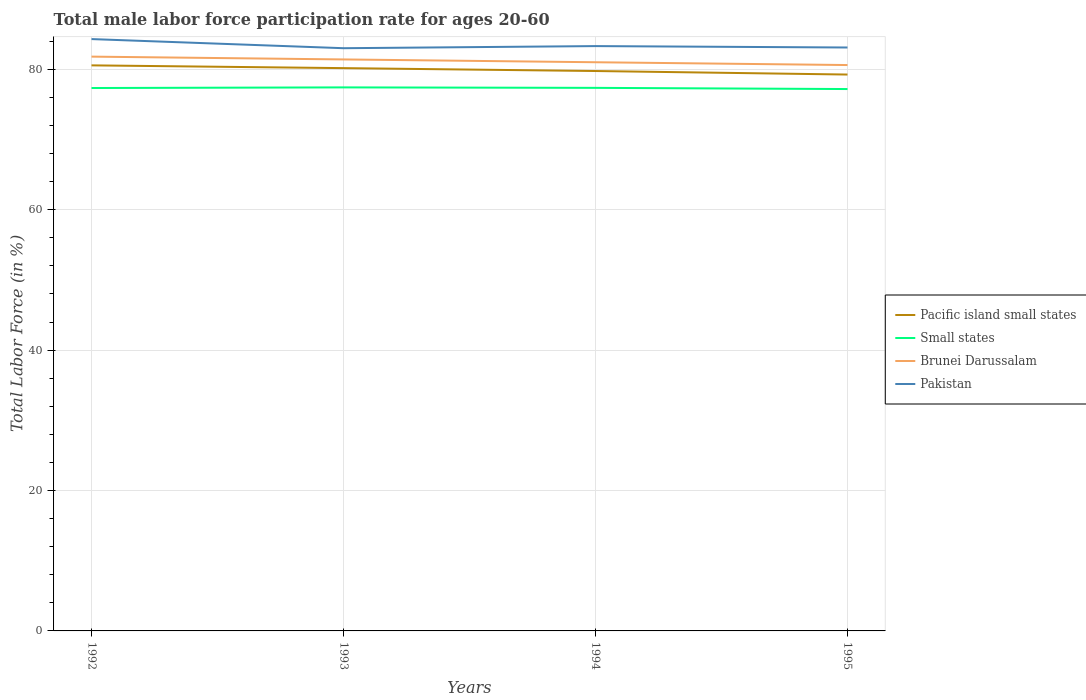Across all years, what is the maximum male labor force participation rate in Pacific island small states?
Provide a short and direct response. 79.25. In which year was the male labor force participation rate in Small states maximum?
Provide a succinct answer. 1995. What is the total male labor force participation rate in Brunei Darussalam in the graph?
Your answer should be very brief. 0.4. What is the difference between the highest and the second highest male labor force participation rate in Pacific island small states?
Ensure brevity in your answer.  1.31. What is the difference between the highest and the lowest male labor force participation rate in Brunei Darussalam?
Your answer should be compact. 2. How many lines are there?
Offer a very short reply. 4. What is the difference between two consecutive major ticks on the Y-axis?
Ensure brevity in your answer.  20. Does the graph contain grids?
Your response must be concise. Yes. Where does the legend appear in the graph?
Offer a terse response. Center right. How many legend labels are there?
Make the answer very short. 4. How are the legend labels stacked?
Offer a terse response. Vertical. What is the title of the graph?
Provide a short and direct response. Total male labor force participation rate for ages 20-60. Does "Philippines" appear as one of the legend labels in the graph?
Your answer should be compact. No. What is the label or title of the X-axis?
Your answer should be compact. Years. What is the label or title of the Y-axis?
Provide a succinct answer. Total Labor Force (in %). What is the Total Labor Force (in %) of Pacific island small states in 1992?
Your answer should be very brief. 80.56. What is the Total Labor Force (in %) of Small states in 1992?
Your answer should be very brief. 77.33. What is the Total Labor Force (in %) of Brunei Darussalam in 1992?
Provide a short and direct response. 81.8. What is the Total Labor Force (in %) of Pakistan in 1992?
Offer a terse response. 84.3. What is the Total Labor Force (in %) in Pacific island small states in 1993?
Your answer should be compact. 80.16. What is the Total Labor Force (in %) in Small states in 1993?
Offer a very short reply. 77.42. What is the Total Labor Force (in %) of Brunei Darussalam in 1993?
Your answer should be compact. 81.4. What is the Total Labor Force (in %) of Pakistan in 1993?
Your answer should be compact. 83. What is the Total Labor Force (in %) of Pacific island small states in 1994?
Provide a succinct answer. 79.75. What is the Total Labor Force (in %) in Small states in 1994?
Keep it short and to the point. 77.35. What is the Total Labor Force (in %) of Brunei Darussalam in 1994?
Offer a very short reply. 81. What is the Total Labor Force (in %) in Pakistan in 1994?
Offer a very short reply. 83.3. What is the Total Labor Force (in %) in Pacific island small states in 1995?
Ensure brevity in your answer.  79.25. What is the Total Labor Force (in %) in Small states in 1995?
Your answer should be compact. 77.18. What is the Total Labor Force (in %) of Brunei Darussalam in 1995?
Offer a terse response. 80.6. What is the Total Labor Force (in %) in Pakistan in 1995?
Your response must be concise. 83.1. Across all years, what is the maximum Total Labor Force (in %) of Pacific island small states?
Provide a succinct answer. 80.56. Across all years, what is the maximum Total Labor Force (in %) of Small states?
Offer a very short reply. 77.42. Across all years, what is the maximum Total Labor Force (in %) of Brunei Darussalam?
Ensure brevity in your answer.  81.8. Across all years, what is the maximum Total Labor Force (in %) of Pakistan?
Your answer should be very brief. 84.3. Across all years, what is the minimum Total Labor Force (in %) in Pacific island small states?
Offer a terse response. 79.25. Across all years, what is the minimum Total Labor Force (in %) of Small states?
Offer a terse response. 77.18. Across all years, what is the minimum Total Labor Force (in %) of Brunei Darussalam?
Your response must be concise. 80.6. Across all years, what is the minimum Total Labor Force (in %) in Pakistan?
Provide a short and direct response. 83. What is the total Total Labor Force (in %) in Pacific island small states in the graph?
Keep it short and to the point. 319.71. What is the total Total Labor Force (in %) in Small states in the graph?
Give a very brief answer. 309.28. What is the total Total Labor Force (in %) in Brunei Darussalam in the graph?
Offer a terse response. 324.8. What is the total Total Labor Force (in %) in Pakistan in the graph?
Ensure brevity in your answer.  333.7. What is the difference between the Total Labor Force (in %) in Pacific island small states in 1992 and that in 1993?
Provide a short and direct response. 0.39. What is the difference between the Total Labor Force (in %) in Small states in 1992 and that in 1993?
Keep it short and to the point. -0.09. What is the difference between the Total Labor Force (in %) of Pakistan in 1992 and that in 1993?
Keep it short and to the point. 1.3. What is the difference between the Total Labor Force (in %) of Pacific island small states in 1992 and that in 1994?
Provide a short and direct response. 0.81. What is the difference between the Total Labor Force (in %) in Small states in 1992 and that in 1994?
Your answer should be compact. -0.02. What is the difference between the Total Labor Force (in %) in Pakistan in 1992 and that in 1994?
Give a very brief answer. 1. What is the difference between the Total Labor Force (in %) of Pacific island small states in 1992 and that in 1995?
Give a very brief answer. 1.31. What is the difference between the Total Labor Force (in %) of Small states in 1992 and that in 1995?
Provide a short and direct response. 0.15. What is the difference between the Total Labor Force (in %) of Brunei Darussalam in 1992 and that in 1995?
Your answer should be very brief. 1.2. What is the difference between the Total Labor Force (in %) in Pakistan in 1992 and that in 1995?
Keep it short and to the point. 1.2. What is the difference between the Total Labor Force (in %) in Pacific island small states in 1993 and that in 1994?
Provide a succinct answer. 0.41. What is the difference between the Total Labor Force (in %) in Small states in 1993 and that in 1994?
Your answer should be very brief. 0.07. What is the difference between the Total Labor Force (in %) in Brunei Darussalam in 1993 and that in 1994?
Provide a short and direct response. 0.4. What is the difference between the Total Labor Force (in %) of Pacific island small states in 1993 and that in 1995?
Offer a very short reply. 0.91. What is the difference between the Total Labor Force (in %) in Small states in 1993 and that in 1995?
Offer a very short reply. 0.24. What is the difference between the Total Labor Force (in %) in Pakistan in 1993 and that in 1995?
Give a very brief answer. -0.1. What is the difference between the Total Labor Force (in %) of Pacific island small states in 1994 and that in 1995?
Keep it short and to the point. 0.5. What is the difference between the Total Labor Force (in %) in Small states in 1994 and that in 1995?
Your answer should be compact. 0.17. What is the difference between the Total Labor Force (in %) in Brunei Darussalam in 1994 and that in 1995?
Give a very brief answer. 0.4. What is the difference between the Total Labor Force (in %) of Pakistan in 1994 and that in 1995?
Your answer should be very brief. 0.2. What is the difference between the Total Labor Force (in %) of Pacific island small states in 1992 and the Total Labor Force (in %) of Small states in 1993?
Give a very brief answer. 3.14. What is the difference between the Total Labor Force (in %) of Pacific island small states in 1992 and the Total Labor Force (in %) of Brunei Darussalam in 1993?
Provide a short and direct response. -0.84. What is the difference between the Total Labor Force (in %) in Pacific island small states in 1992 and the Total Labor Force (in %) in Pakistan in 1993?
Provide a succinct answer. -2.44. What is the difference between the Total Labor Force (in %) of Small states in 1992 and the Total Labor Force (in %) of Brunei Darussalam in 1993?
Offer a very short reply. -4.07. What is the difference between the Total Labor Force (in %) in Small states in 1992 and the Total Labor Force (in %) in Pakistan in 1993?
Keep it short and to the point. -5.67. What is the difference between the Total Labor Force (in %) of Pacific island small states in 1992 and the Total Labor Force (in %) of Small states in 1994?
Give a very brief answer. 3.2. What is the difference between the Total Labor Force (in %) of Pacific island small states in 1992 and the Total Labor Force (in %) of Brunei Darussalam in 1994?
Keep it short and to the point. -0.44. What is the difference between the Total Labor Force (in %) in Pacific island small states in 1992 and the Total Labor Force (in %) in Pakistan in 1994?
Offer a very short reply. -2.74. What is the difference between the Total Labor Force (in %) of Small states in 1992 and the Total Labor Force (in %) of Brunei Darussalam in 1994?
Your response must be concise. -3.67. What is the difference between the Total Labor Force (in %) in Small states in 1992 and the Total Labor Force (in %) in Pakistan in 1994?
Provide a short and direct response. -5.97. What is the difference between the Total Labor Force (in %) in Pacific island small states in 1992 and the Total Labor Force (in %) in Small states in 1995?
Ensure brevity in your answer.  3.37. What is the difference between the Total Labor Force (in %) of Pacific island small states in 1992 and the Total Labor Force (in %) of Brunei Darussalam in 1995?
Make the answer very short. -0.04. What is the difference between the Total Labor Force (in %) of Pacific island small states in 1992 and the Total Labor Force (in %) of Pakistan in 1995?
Provide a short and direct response. -2.54. What is the difference between the Total Labor Force (in %) of Small states in 1992 and the Total Labor Force (in %) of Brunei Darussalam in 1995?
Offer a terse response. -3.27. What is the difference between the Total Labor Force (in %) in Small states in 1992 and the Total Labor Force (in %) in Pakistan in 1995?
Provide a short and direct response. -5.77. What is the difference between the Total Labor Force (in %) of Pacific island small states in 1993 and the Total Labor Force (in %) of Small states in 1994?
Provide a succinct answer. 2.81. What is the difference between the Total Labor Force (in %) of Pacific island small states in 1993 and the Total Labor Force (in %) of Brunei Darussalam in 1994?
Offer a terse response. -0.84. What is the difference between the Total Labor Force (in %) of Pacific island small states in 1993 and the Total Labor Force (in %) of Pakistan in 1994?
Ensure brevity in your answer.  -3.14. What is the difference between the Total Labor Force (in %) of Small states in 1993 and the Total Labor Force (in %) of Brunei Darussalam in 1994?
Your answer should be very brief. -3.58. What is the difference between the Total Labor Force (in %) in Small states in 1993 and the Total Labor Force (in %) in Pakistan in 1994?
Offer a terse response. -5.88. What is the difference between the Total Labor Force (in %) in Brunei Darussalam in 1993 and the Total Labor Force (in %) in Pakistan in 1994?
Make the answer very short. -1.9. What is the difference between the Total Labor Force (in %) in Pacific island small states in 1993 and the Total Labor Force (in %) in Small states in 1995?
Offer a very short reply. 2.98. What is the difference between the Total Labor Force (in %) in Pacific island small states in 1993 and the Total Labor Force (in %) in Brunei Darussalam in 1995?
Provide a succinct answer. -0.44. What is the difference between the Total Labor Force (in %) in Pacific island small states in 1993 and the Total Labor Force (in %) in Pakistan in 1995?
Provide a succinct answer. -2.94. What is the difference between the Total Labor Force (in %) in Small states in 1993 and the Total Labor Force (in %) in Brunei Darussalam in 1995?
Your response must be concise. -3.18. What is the difference between the Total Labor Force (in %) in Small states in 1993 and the Total Labor Force (in %) in Pakistan in 1995?
Make the answer very short. -5.68. What is the difference between the Total Labor Force (in %) of Pacific island small states in 1994 and the Total Labor Force (in %) of Small states in 1995?
Offer a terse response. 2.57. What is the difference between the Total Labor Force (in %) of Pacific island small states in 1994 and the Total Labor Force (in %) of Brunei Darussalam in 1995?
Keep it short and to the point. -0.85. What is the difference between the Total Labor Force (in %) in Pacific island small states in 1994 and the Total Labor Force (in %) in Pakistan in 1995?
Provide a short and direct response. -3.35. What is the difference between the Total Labor Force (in %) in Small states in 1994 and the Total Labor Force (in %) in Brunei Darussalam in 1995?
Provide a succinct answer. -3.25. What is the difference between the Total Labor Force (in %) in Small states in 1994 and the Total Labor Force (in %) in Pakistan in 1995?
Offer a terse response. -5.75. What is the difference between the Total Labor Force (in %) in Brunei Darussalam in 1994 and the Total Labor Force (in %) in Pakistan in 1995?
Keep it short and to the point. -2.1. What is the average Total Labor Force (in %) of Pacific island small states per year?
Keep it short and to the point. 79.93. What is the average Total Labor Force (in %) of Small states per year?
Your answer should be compact. 77.32. What is the average Total Labor Force (in %) of Brunei Darussalam per year?
Your answer should be compact. 81.2. What is the average Total Labor Force (in %) in Pakistan per year?
Provide a short and direct response. 83.42. In the year 1992, what is the difference between the Total Labor Force (in %) in Pacific island small states and Total Labor Force (in %) in Small states?
Your response must be concise. 3.23. In the year 1992, what is the difference between the Total Labor Force (in %) of Pacific island small states and Total Labor Force (in %) of Brunei Darussalam?
Your answer should be compact. -1.24. In the year 1992, what is the difference between the Total Labor Force (in %) in Pacific island small states and Total Labor Force (in %) in Pakistan?
Your answer should be compact. -3.74. In the year 1992, what is the difference between the Total Labor Force (in %) of Small states and Total Labor Force (in %) of Brunei Darussalam?
Keep it short and to the point. -4.47. In the year 1992, what is the difference between the Total Labor Force (in %) of Small states and Total Labor Force (in %) of Pakistan?
Provide a short and direct response. -6.97. In the year 1992, what is the difference between the Total Labor Force (in %) in Brunei Darussalam and Total Labor Force (in %) in Pakistan?
Offer a very short reply. -2.5. In the year 1993, what is the difference between the Total Labor Force (in %) in Pacific island small states and Total Labor Force (in %) in Small states?
Provide a short and direct response. 2.74. In the year 1993, what is the difference between the Total Labor Force (in %) of Pacific island small states and Total Labor Force (in %) of Brunei Darussalam?
Provide a short and direct response. -1.24. In the year 1993, what is the difference between the Total Labor Force (in %) in Pacific island small states and Total Labor Force (in %) in Pakistan?
Keep it short and to the point. -2.84. In the year 1993, what is the difference between the Total Labor Force (in %) in Small states and Total Labor Force (in %) in Brunei Darussalam?
Offer a very short reply. -3.98. In the year 1993, what is the difference between the Total Labor Force (in %) in Small states and Total Labor Force (in %) in Pakistan?
Offer a very short reply. -5.58. In the year 1994, what is the difference between the Total Labor Force (in %) in Pacific island small states and Total Labor Force (in %) in Small states?
Make the answer very short. 2.4. In the year 1994, what is the difference between the Total Labor Force (in %) of Pacific island small states and Total Labor Force (in %) of Brunei Darussalam?
Give a very brief answer. -1.25. In the year 1994, what is the difference between the Total Labor Force (in %) in Pacific island small states and Total Labor Force (in %) in Pakistan?
Provide a short and direct response. -3.55. In the year 1994, what is the difference between the Total Labor Force (in %) of Small states and Total Labor Force (in %) of Brunei Darussalam?
Your answer should be very brief. -3.65. In the year 1994, what is the difference between the Total Labor Force (in %) of Small states and Total Labor Force (in %) of Pakistan?
Your answer should be compact. -5.95. In the year 1995, what is the difference between the Total Labor Force (in %) of Pacific island small states and Total Labor Force (in %) of Small states?
Your answer should be very brief. 2.07. In the year 1995, what is the difference between the Total Labor Force (in %) in Pacific island small states and Total Labor Force (in %) in Brunei Darussalam?
Ensure brevity in your answer.  -1.35. In the year 1995, what is the difference between the Total Labor Force (in %) of Pacific island small states and Total Labor Force (in %) of Pakistan?
Your answer should be compact. -3.85. In the year 1995, what is the difference between the Total Labor Force (in %) in Small states and Total Labor Force (in %) in Brunei Darussalam?
Give a very brief answer. -3.42. In the year 1995, what is the difference between the Total Labor Force (in %) of Small states and Total Labor Force (in %) of Pakistan?
Your answer should be very brief. -5.92. What is the ratio of the Total Labor Force (in %) of Pacific island small states in 1992 to that in 1993?
Offer a terse response. 1. What is the ratio of the Total Labor Force (in %) of Brunei Darussalam in 1992 to that in 1993?
Make the answer very short. 1. What is the ratio of the Total Labor Force (in %) in Pakistan in 1992 to that in 1993?
Offer a terse response. 1.02. What is the ratio of the Total Labor Force (in %) in Pacific island small states in 1992 to that in 1994?
Your answer should be very brief. 1.01. What is the ratio of the Total Labor Force (in %) in Brunei Darussalam in 1992 to that in 1994?
Offer a very short reply. 1.01. What is the ratio of the Total Labor Force (in %) in Pakistan in 1992 to that in 1994?
Make the answer very short. 1.01. What is the ratio of the Total Labor Force (in %) of Pacific island small states in 1992 to that in 1995?
Your answer should be very brief. 1.02. What is the ratio of the Total Labor Force (in %) of Brunei Darussalam in 1992 to that in 1995?
Your response must be concise. 1.01. What is the ratio of the Total Labor Force (in %) of Pakistan in 1992 to that in 1995?
Your answer should be very brief. 1.01. What is the ratio of the Total Labor Force (in %) of Pacific island small states in 1993 to that in 1994?
Your answer should be compact. 1.01. What is the ratio of the Total Labor Force (in %) of Small states in 1993 to that in 1994?
Your answer should be compact. 1. What is the ratio of the Total Labor Force (in %) of Pacific island small states in 1993 to that in 1995?
Ensure brevity in your answer.  1.01. What is the ratio of the Total Labor Force (in %) in Small states in 1993 to that in 1995?
Your answer should be very brief. 1. What is the ratio of the Total Labor Force (in %) of Brunei Darussalam in 1993 to that in 1995?
Ensure brevity in your answer.  1.01. What is the ratio of the Total Labor Force (in %) of Small states in 1994 to that in 1995?
Your answer should be compact. 1. What is the ratio of the Total Labor Force (in %) of Brunei Darussalam in 1994 to that in 1995?
Give a very brief answer. 1. What is the difference between the highest and the second highest Total Labor Force (in %) in Pacific island small states?
Provide a succinct answer. 0.39. What is the difference between the highest and the second highest Total Labor Force (in %) in Small states?
Your answer should be compact. 0.07. What is the difference between the highest and the second highest Total Labor Force (in %) of Brunei Darussalam?
Ensure brevity in your answer.  0.4. What is the difference between the highest and the lowest Total Labor Force (in %) of Pacific island small states?
Make the answer very short. 1.31. What is the difference between the highest and the lowest Total Labor Force (in %) in Small states?
Offer a very short reply. 0.24. 